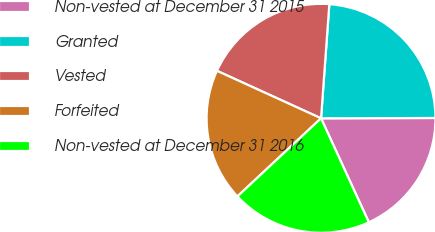Convert chart to OTSL. <chart><loc_0><loc_0><loc_500><loc_500><pie_chart><fcel>Non-vested at December 31 2015<fcel>Granted<fcel>Vested<fcel>Forfeited<fcel>Non-vested at December 31 2016<nl><fcel>18.19%<fcel>23.8%<fcel>19.34%<fcel>18.77%<fcel>19.9%<nl></chart> 